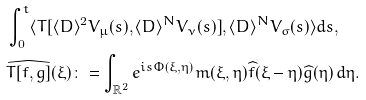Convert formula to latex. <formula><loc_0><loc_0><loc_500><loc_500>& \int _ { 0 } ^ { t } \langle T [ \langle D \rangle ^ { 2 } V _ { \mu } ( s ) , \langle D \rangle ^ { N } V _ { \nu } ( s ) ] , \langle D \rangle ^ { N } V _ { \sigma } ( s ) \rangle d s , \\ & \widehat { T [ f , g ] } ( \xi ) \colon = \int _ { \mathbb { R } ^ { 2 } } e ^ { i s \Phi ( \xi , \eta ) } m ( \xi , \eta ) \widehat { f } ( \xi - \eta ) \widehat { g } ( \eta ) \, d \eta .</formula> 